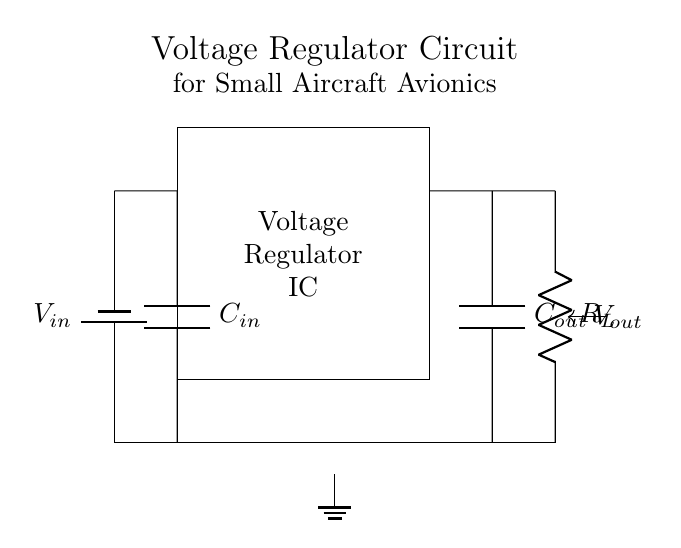What is the input voltage labeled as in this circuit? The input voltage in the circuit is labeled as V_{in}, which is located at the top left corner of the diagram where the battery symbol is drawn.
Answer: V_{in} What is the role of the component labeled C_{in}? C_{in} is an input capacitor. Its role is to stabilize the input voltage to the voltage regulator by filtering out noise and smoothing any fluctuations from the input power source.
Answer: Input capacitor What is the output voltage of the circuit? The output voltage is denoted as V_{out}, found on the right side of the circuit where it connects to the load resistor.
Answer: V_{out} Name one of the components connected in parallel to the load resistor R_L. The component connected in parallel to the load resistor R_L is the output capacitor C_{out}, which helps stabilize the output voltage by filtering noise and providing a storage reservoir of charge.
Answer: Output capacitor How many capacitors are present in this voltage regulator circuit? There are two capacitors in this voltage regulator circuit: the input capacitor C_{in} and the output capacitor C_{out}.
Answer: Two What is the purpose of the voltage regulator IC in this circuit? The voltage regulator IC regulates the voltage provided to the avionics systems, ensuring a stable output voltage (V_{out}) regardless of variations in input voltage (V_{in}) or load conditions.
Answer: Regulatory function Which direction does the current flow from the battery to the load? The current flows from the positive terminal of the battery (V_{in}) down through C_{in}, then through the voltage regulator IC, and finally through the load resistor R_L towards ground.
Answer: Downwards 